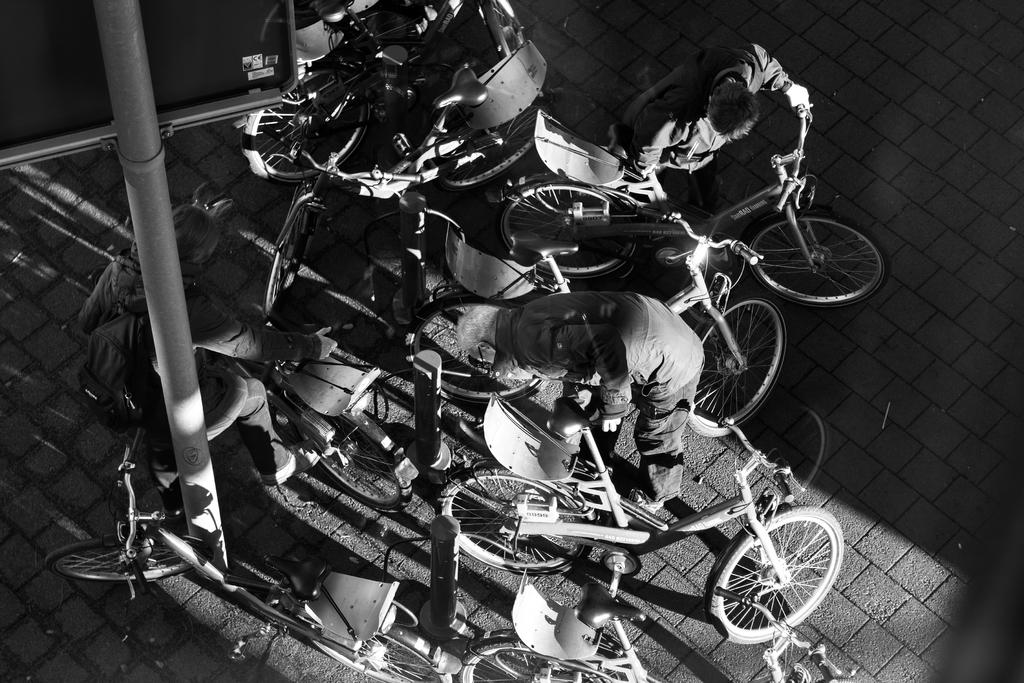What is the color scheme of the image? The picture is black and white. What type of vehicles can be seen in the image? There are bicycles in the image. Are there any people present in the image? Yes, there are people in the image. What other objects can be seen in the image besides bicycles and people? There is a pole and a board in the image. What type of iron is being used by the people in the image? There is no iron present in the image; it features bicycles, people, a pole, and a board. Can you recite the verse that is written on the board in the image? There is no verse visible on the board in the image; it is a plain board. 